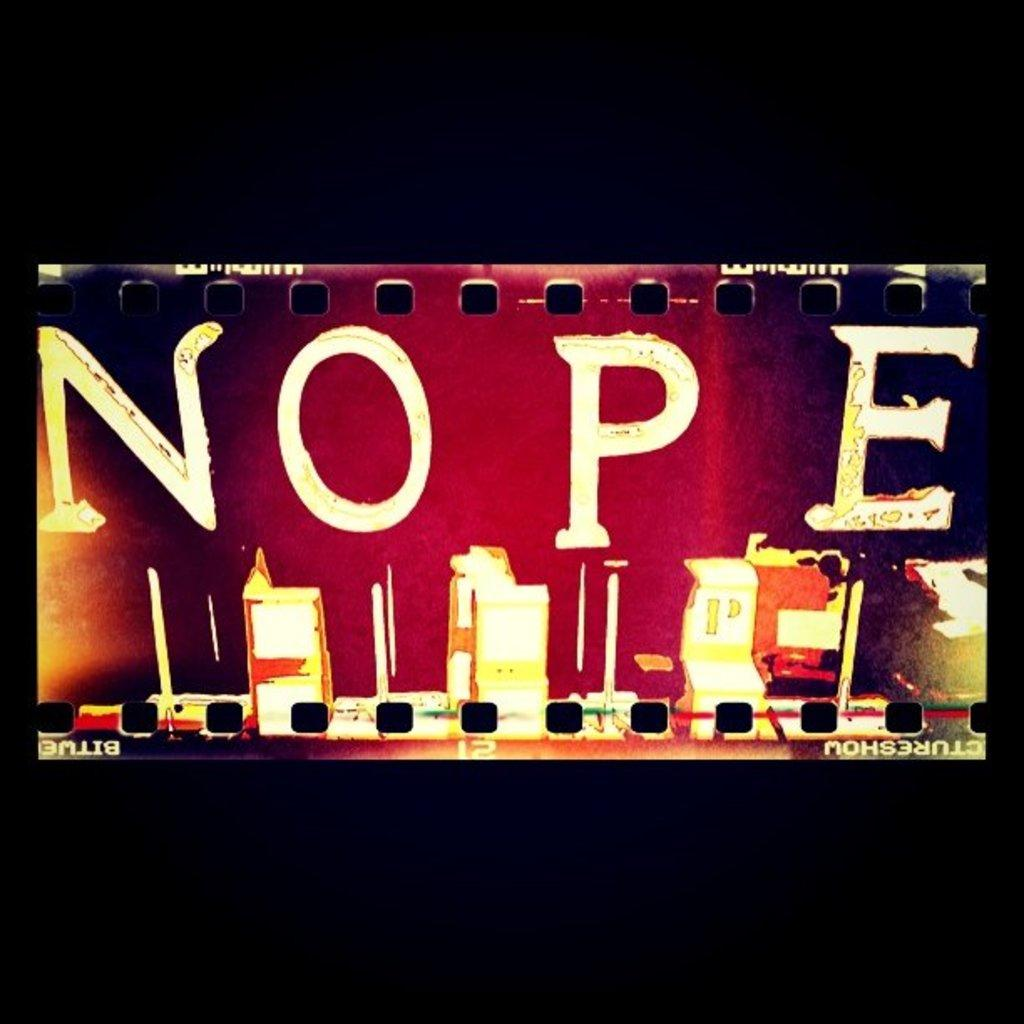<image>
Relay a brief, clear account of the picture shown. A colorful section of film has the word NOPE printed on it. 